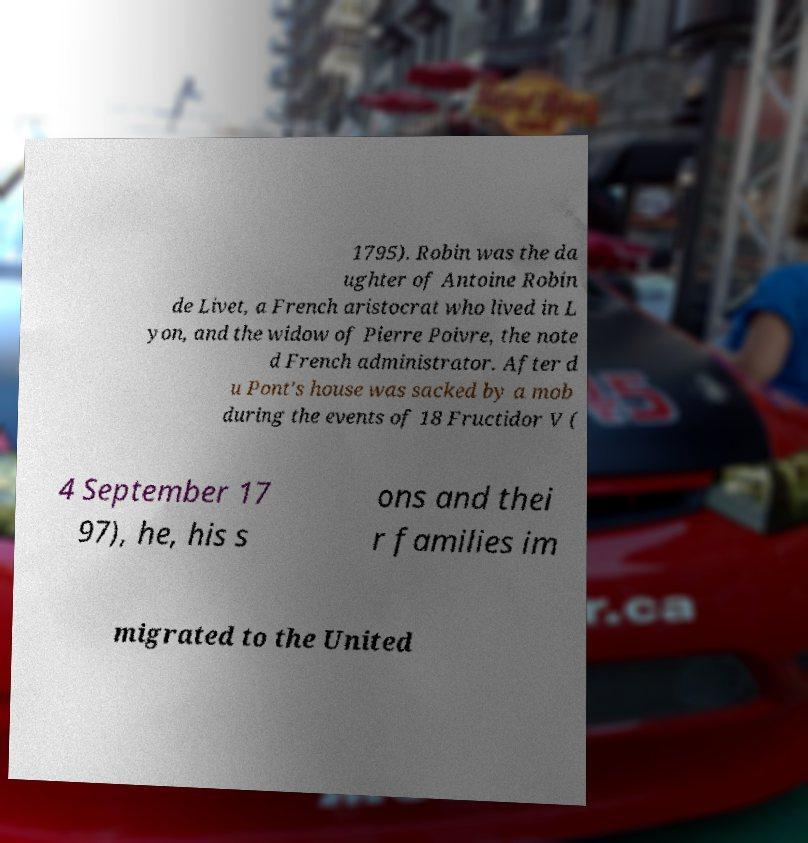Please identify and transcribe the text found in this image. 1795). Robin was the da ughter of Antoine Robin de Livet, a French aristocrat who lived in L yon, and the widow of Pierre Poivre, the note d French administrator. After d u Pont's house was sacked by a mob during the events of 18 Fructidor V ( 4 September 17 97), he, his s ons and thei r families im migrated to the United 